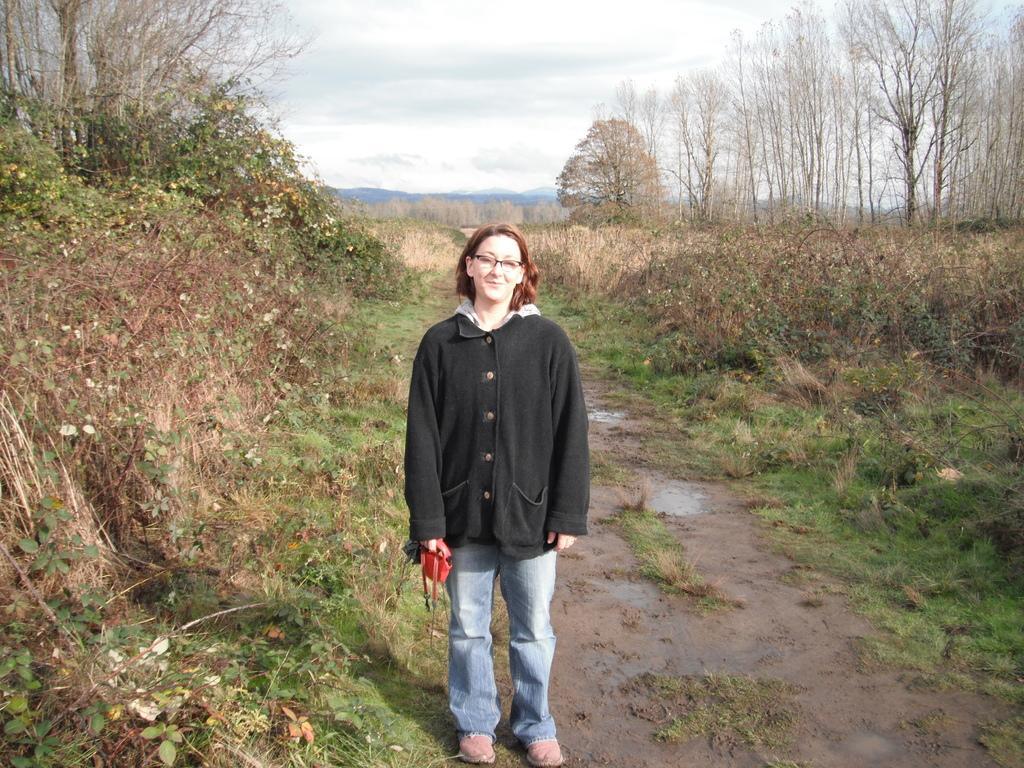How would you summarize this image in a sentence or two? In this picture there is a woman standing and smiling and holding a bag. We can see plants, grass, mud and trees. In the background of the image we can see hills and sky. 